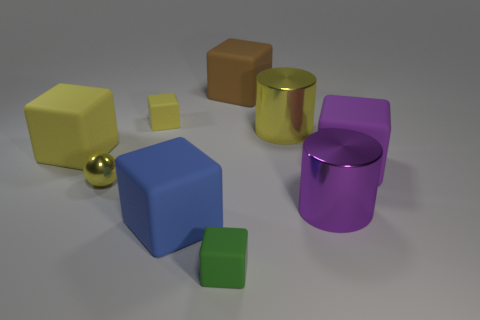There is a block that is right of the big brown rubber cube; what material is it?
Your answer should be compact. Rubber. Are there fewer tiny blocks in front of the tiny yellow matte block than big purple objects?
Your answer should be very brief. Yes. Is the shape of the small yellow shiny thing the same as the small yellow matte object?
Provide a succinct answer. No. Is there any other thing that is the same shape as the purple matte object?
Offer a terse response. Yes. Are there any large blue matte objects?
Offer a very short reply. Yes. Do the blue object and the big yellow object left of the large blue object have the same shape?
Provide a short and direct response. Yes. What material is the large blue cube in front of the big yellow object left of the green matte object?
Your answer should be compact. Rubber. The small shiny sphere is what color?
Your response must be concise. Yellow. There is a object that is in front of the large blue matte object; is it the same color as the tiny matte block that is behind the large purple cube?
Ensure brevity in your answer.  No. What size is the green matte thing that is the same shape as the big yellow rubber thing?
Your response must be concise. Small. 